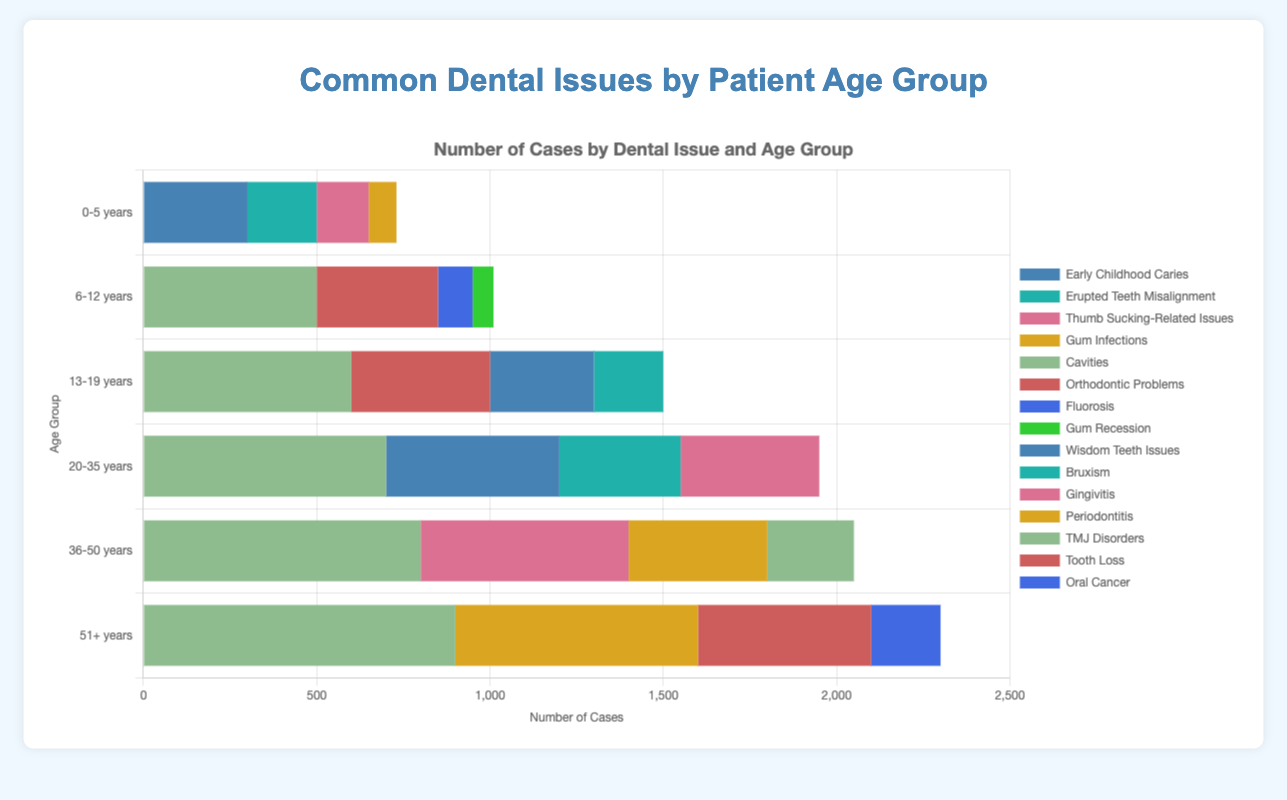Which age group has the highest number of cases of cavities? Looking at the height of the bars representing cavities across all age groups, the group 51+ years has the tallest bar for cavities.
Answer: 51+ years What is the total number of orthodontic problem cases across all age groups? Summing up the number of cases for orthodontic problems in each age group: 6-12 years (350) + 13-19 years (400) = 750.
Answer: 750 Between the age groups 20-35 years and 36-50 years, which has more cases of gingivitis, and by how much? The number of gingivitis cases for 20-35 years is 400, and for 36-50 years it is 600. The difference is 600 - 400 = 200.
Answer: 36-50 years, by 200 What is the average number of bruxism cases in the age groups 13-19 years and 20-35 years? Adding the number of bruxism cases for both age groups: 13-19 years (200) + 20-35 years (350) = 550. The average is calculated by dividing the total by the number of groups: 550 / 2 = 275.
Answer: 275 Which dental issue has the highest number of cases in the 0-5 years age group? By comparing the heights of the bars in the 0-5 years group for all dental issues, Early Childhood Caries has the highest bar.
Answer: Early Childhood Caries How does the number of thumb sucking-related issues in the 0-5 years age group compare to the number of wisdom teeth issues in the 20-35 years age group? The number of thumb sucking-related issues in 0-5 years is 150, and the number of wisdom teeth issues in 20-35 years is 500. 500 is greater than 150.
Answer: Wisdom teeth issues in 20-35 years are greater Is the number of cavities in 13-19 years greater than the sum of gum infections in 0-5 years and fluorosis in 6-12 years? The number of cavities in 13-19 years is 600. Sum of gum infections in 0-5 years is 80 and fluorosis in 6-12 years is 100: 80 + 100 = 180. 600 is greater than 180.
Answer: Yes What is the difference in the number of tooth loss cases between the 51+ years and 36-50 years age groups? The number of tooth loss cases in 51+ years is 500, and 36-50 years group doesn't list tooth loss cases. So, the difference is 500 - 0 = 500.
Answer: 500 Which age group has the least number of overall dental issues mentioned? By adding the number of cases for all issues in each age group and comparing:
0-5 years: 300 + 200 + 150 + 80 = 730
6-12 years: 500 + 350 + 100 + 60 = 1010
13-19 years: 600 + 300 + 200 + 400 = 1500
20-35 years: 700 + 500 + 400 + 350 = 1950
36-50 years: 800 + 600 + 400 + 250 = 2050
51+ years: 900 + 700 + 500 + 200 = 2300
The 0-5 years age group has the lowest total.
Answer: 0-5 years 